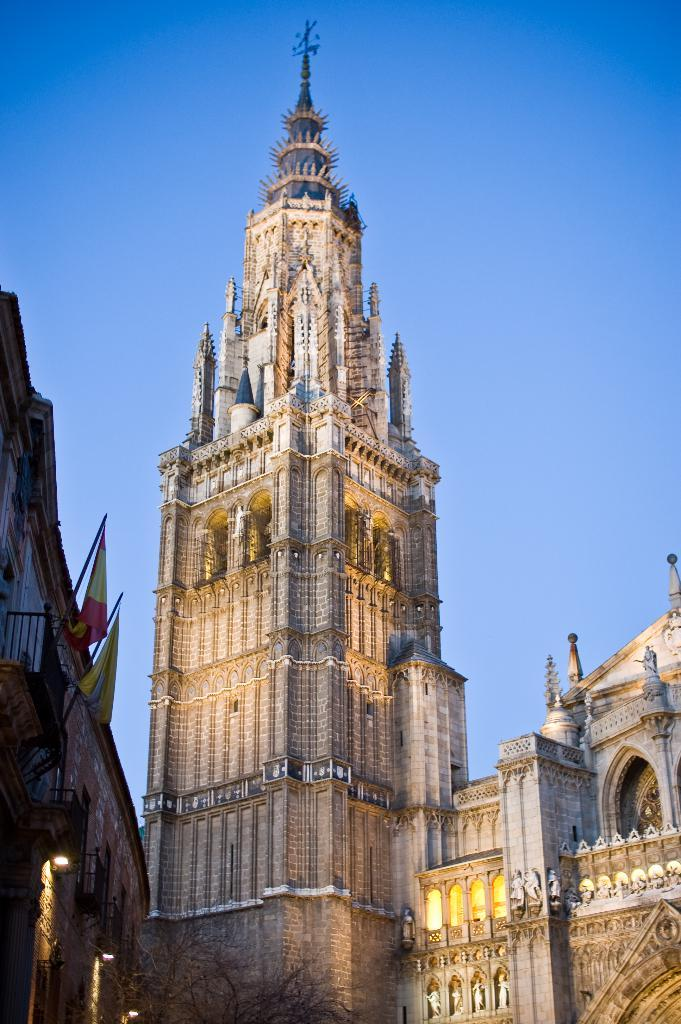What is the main structure in the center of the image? There is a building in the center of the image. What can be seen on the left side of the image? There are flags and a tree on the left side of the image, as well as another building. What is visible in the background of the image? The sky is visible in the background of the image. How many wristwatches can be seen on the tree in the image? There are no wristwatches present in the image. 